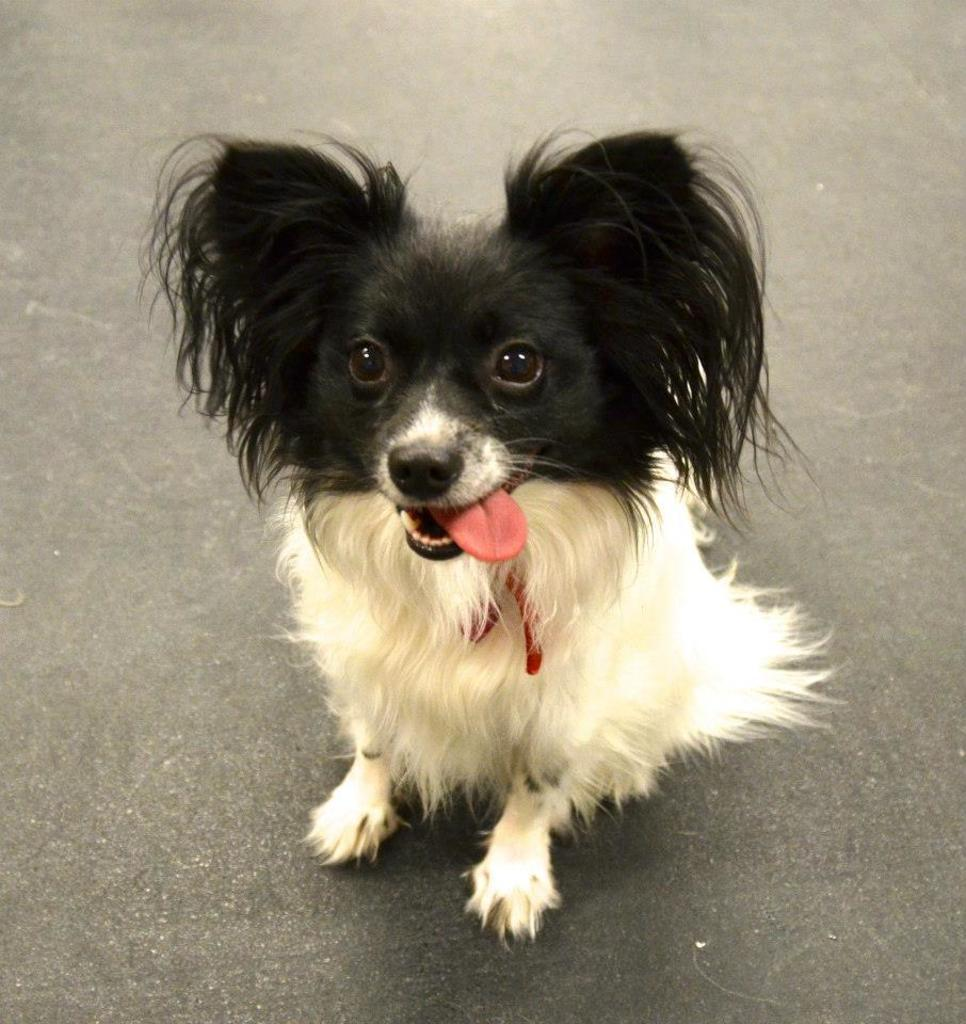What type of animal is present in the image? There is a dog in the image. What colors can be seen on the dog? The dog is black and white in color. Where is the dog located in the image? The dog is sitting on the road. What can be seen in the background of the image? There is a road visible in the image. What type of alarm system is installed on the dog in the image? There is no alarm system installed on the dog in the image; it is a regular dog without any electronic devices. 